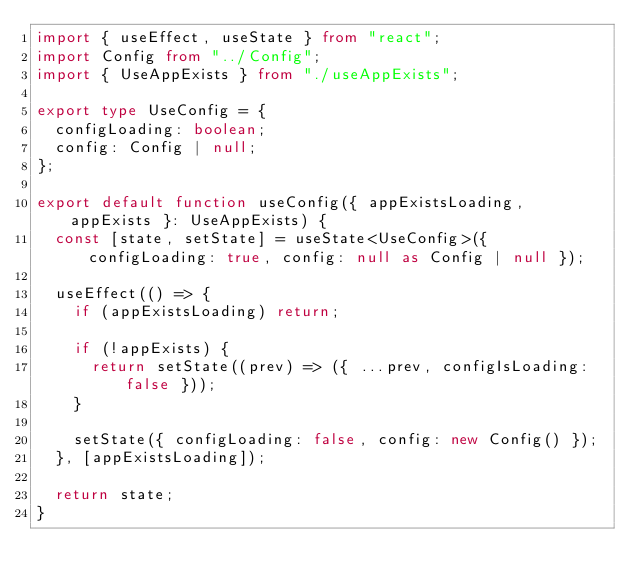<code> <loc_0><loc_0><loc_500><loc_500><_TypeScript_>import { useEffect, useState } from "react";
import Config from "../Config";
import { UseAppExists } from "./useAppExists";

export type UseConfig = {
  configLoading: boolean;
  config: Config | null;
};

export default function useConfig({ appExistsLoading, appExists }: UseAppExists) {
  const [state, setState] = useState<UseConfig>({ configLoading: true, config: null as Config | null });

  useEffect(() => {
    if (appExistsLoading) return;

    if (!appExists) {
      return setState((prev) => ({ ...prev, configIsLoading: false }));
    }

    setState({ configLoading: false, config: new Config() });
  }, [appExistsLoading]);

  return state;
}
</code> 